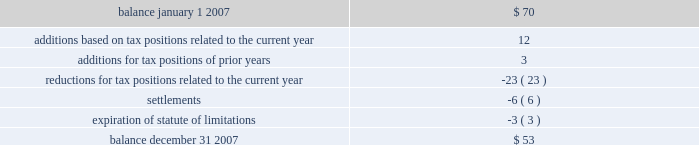Notes to consolidated financial statements note 11 .
Income taxes 2013 ( continued ) the federal income tax return for 2006 is subject to examination by the irs .
In addition for 2007 and 2008 , the irs has invited the company to participate in the compliance assurance process ( 201ccap 201d ) , which is a voluntary program for a limited number of large corporations .
Under cap , the irs conducts a real-time audit and works contemporaneously with the company to resolve any issues prior to the filing of the tax return .
The company has agreed to participate .
The company believes this approach should reduce tax-related uncertainties , if any .
The company and/or its subsidiaries also file income tax returns in various state , local and foreign jurisdictions .
These returns , with few exceptions , are no longer subject to examination by the various taxing authorities before as discussed in note 1 , the company adopted the provisions of fin no .
48 , 201caccounting for uncertainty in income taxes , 201d on january 1 , 2007 .
As a result of the implementation of fin no .
48 , the company recognized a decrease to beginning retained earnings on january 1 , 2007 of $ 37 million .
The total amount of unrecognized tax benefits as of the date of adoption was approximately $ 70 million .
Included in the balance at january 1 , 2007 , were $ 51 million of tax positions that if recognized would affect the effective tax rate .
A reconciliation of the beginning and ending amount of unrecognized tax benefits is as follows : ( in millions ) .
The company anticipates that it is reasonably possible that payments of approximately $ 2 million will be made primarily due to the conclusion of state income tax examinations within the next 12 months .
Additionally , certain state and foreign income tax returns will no longer be subject to examination and as a result , there is a reasonable possibility that the amount of unrecognized tax benefits will decrease by $ 7 million .
At december 31 , 2007 , there were $ 42 million of tax benefits that if recognized would affect the effective rate .
The company recognizes interest accrued related to : ( 1 ) unrecognized tax benefits in interest expense and ( 2 ) tax refund claims in other revenues on the consolidated statements of income .
The company recognizes penalties in income tax expense ( benefit ) on the consolidated statements of income .
During 2007 , the company recorded charges of approximately $ 4 million for interest expense and $ 2 million for penalties .
Provision has been made for the expected u.s .
Federal income tax liabilities applicable to undistributed earnings of subsidiaries , except for certain subsidiaries for which the company intends to invest the undistributed earnings indefinitely , or recover such undistributed earnings tax-free .
At december 31 , 2007 , the company has not provided deferred taxes of $ 126 million , if sold through a taxable sale , on $ 361 million of undistributed earnings related to a domestic affiliate .
The determination of the amount of the unrecognized deferred tax liability related to the undistributed earnings of foreign subsidiaries is not practicable .
In connection with a non-recurring distribution of $ 850 million to diamond offshore from a foreign subsidiary , a portion of which consisted of earnings of the subsidiary that had not previously been subjected to u.s .
Federal income tax , diamond offshore recognized $ 59 million of u.s .
Federal income tax expense as a result of the distribution .
It remains diamond offshore 2019s intention to indefinitely reinvest future earnings of the subsidiary to finance foreign activities .
Total income tax expense for the years ended december 31 , 2007 , 2006 and 2005 , was different than the amounts of $ 1601 million , $ 1557 million and $ 639 million , computed by applying the statutory u.s .
Federal income tax rate of 35% ( 35 % ) to income before income taxes and minority interest for each of the years. .
What was the actual change in the unrecognized tax benefits in 2007 based on the reconciliation in millions? 
Computations: (53 - 70)
Answer: -17.0. Notes to consolidated financial statements note 11 .
Income taxes 2013 ( continued ) the federal income tax return for 2006 is subject to examination by the irs .
In addition for 2007 and 2008 , the irs has invited the company to participate in the compliance assurance process ( 201ccap 201d ) , which is a voluntary program for a limited number of large corporations .
Under cap , the irs conducts a real-time audit and works contemporaneously with the company to resolve any issues prior to the filing of the tax return .
The company has agreed to participate .
The company believes this approach should reduce tax-related uncertainties , if any .
The company and/or its subsidiaries also file income tax returns in various state , local and foreign jurisdictions .
These returns , with few exceptions , are no longer subject to examination by the various taxing authorities before as discussed in note 1 , the company adopted the provisions of fin no .
48 , 201caccounting for uncertainty in income taxes , 201d on january 1 , 2007 .
As a result of the implementation of fin no .
48 , the company recognized a decrease to beginning retained earnings on january 1 , 2007 of $ 37 million .
The total amount of unrecognized tax benefits as of the date of adoption was approximately $ 70 million .
Included in the balance at january 1 , 2007 , were $ 51 million of tax positions that if recognized would affect the effective tax rate .
A reconciliation of the beginning and ending amount of unrecognized tax benefits is as follows : ( in millions ) .
The company anticipates that it is reasonably possible that payments of approximately $ 2 million will be made primarily due to the conclusion of state income tax examinations within the next 12 months .
Additionally , certain state and foreign income tax returns will no longer be subject to examination and as a result , there is a reasonable possibility that the amount of unrecognized tax benefits will decrease by $ 7 million .
At december 31 , 2007 , there were $ 42 million of tax benefits that if recognized would affect the effective rate .
The company recognizes interest accrued related to : ( 1 ) unrecognized tax benefits in interest expense and ( 2 ) tax refund claims in other revenues on the consolidated statements of income .
The company recognizes penalties in income tax expense ( benefit ) on the consolidated statements of income .
During 2007 , the company recorded charges of approximately $ 4 million for interest expense and $ 2 million for penalties .
Provision has been made for the expected u.s .
Federal income tax liabilities applicable to undistributed earnings of subsidiaries , except for certain subsidiaries for which the company intends to invest the undistributed earnings indefinitely , or recover such undistributed earnings tax-free .
At december 31 , 2007 , the company has not provided deferred taxes of $ 126 million , if sold through a taxable sale , on $ 361 million of undistributed earnings related to a domestic affiliate .
The determination of the amount of the unrecognized deferred tax liability related to the undistributed earnings of foreign subsidiaries is not practicable .
In connection with a non-recurring distribution of $ 850 million to diamond offshore from a foreign subsidiary , a portion of which consisted of earnings of the subsidiary that had not previously been subjected to u.s .
Federal income tax , diamond offshore recognized $ 59 million of u.s .
Federal income tax expense as a result of the distribution .
It remains diamond offshore 2019s intention to indefinitely reinvest future earnings of the subsidiary to finance foreign activities .
Total income tax expense for the years ended december 31 , 2007 , 2006 and 2005 , was different than the amounts of $ 1601 million , $ 1557 million and $ 639 million , computed by applying the statutory u.s .
Federal income tax rate of 35% ( 35 % ) to income before income taxes and minority interest for each of the years. .
What is the income before tax in 2007? 
Computations: (1601 / 35%)
Answer: 4574.28571. 